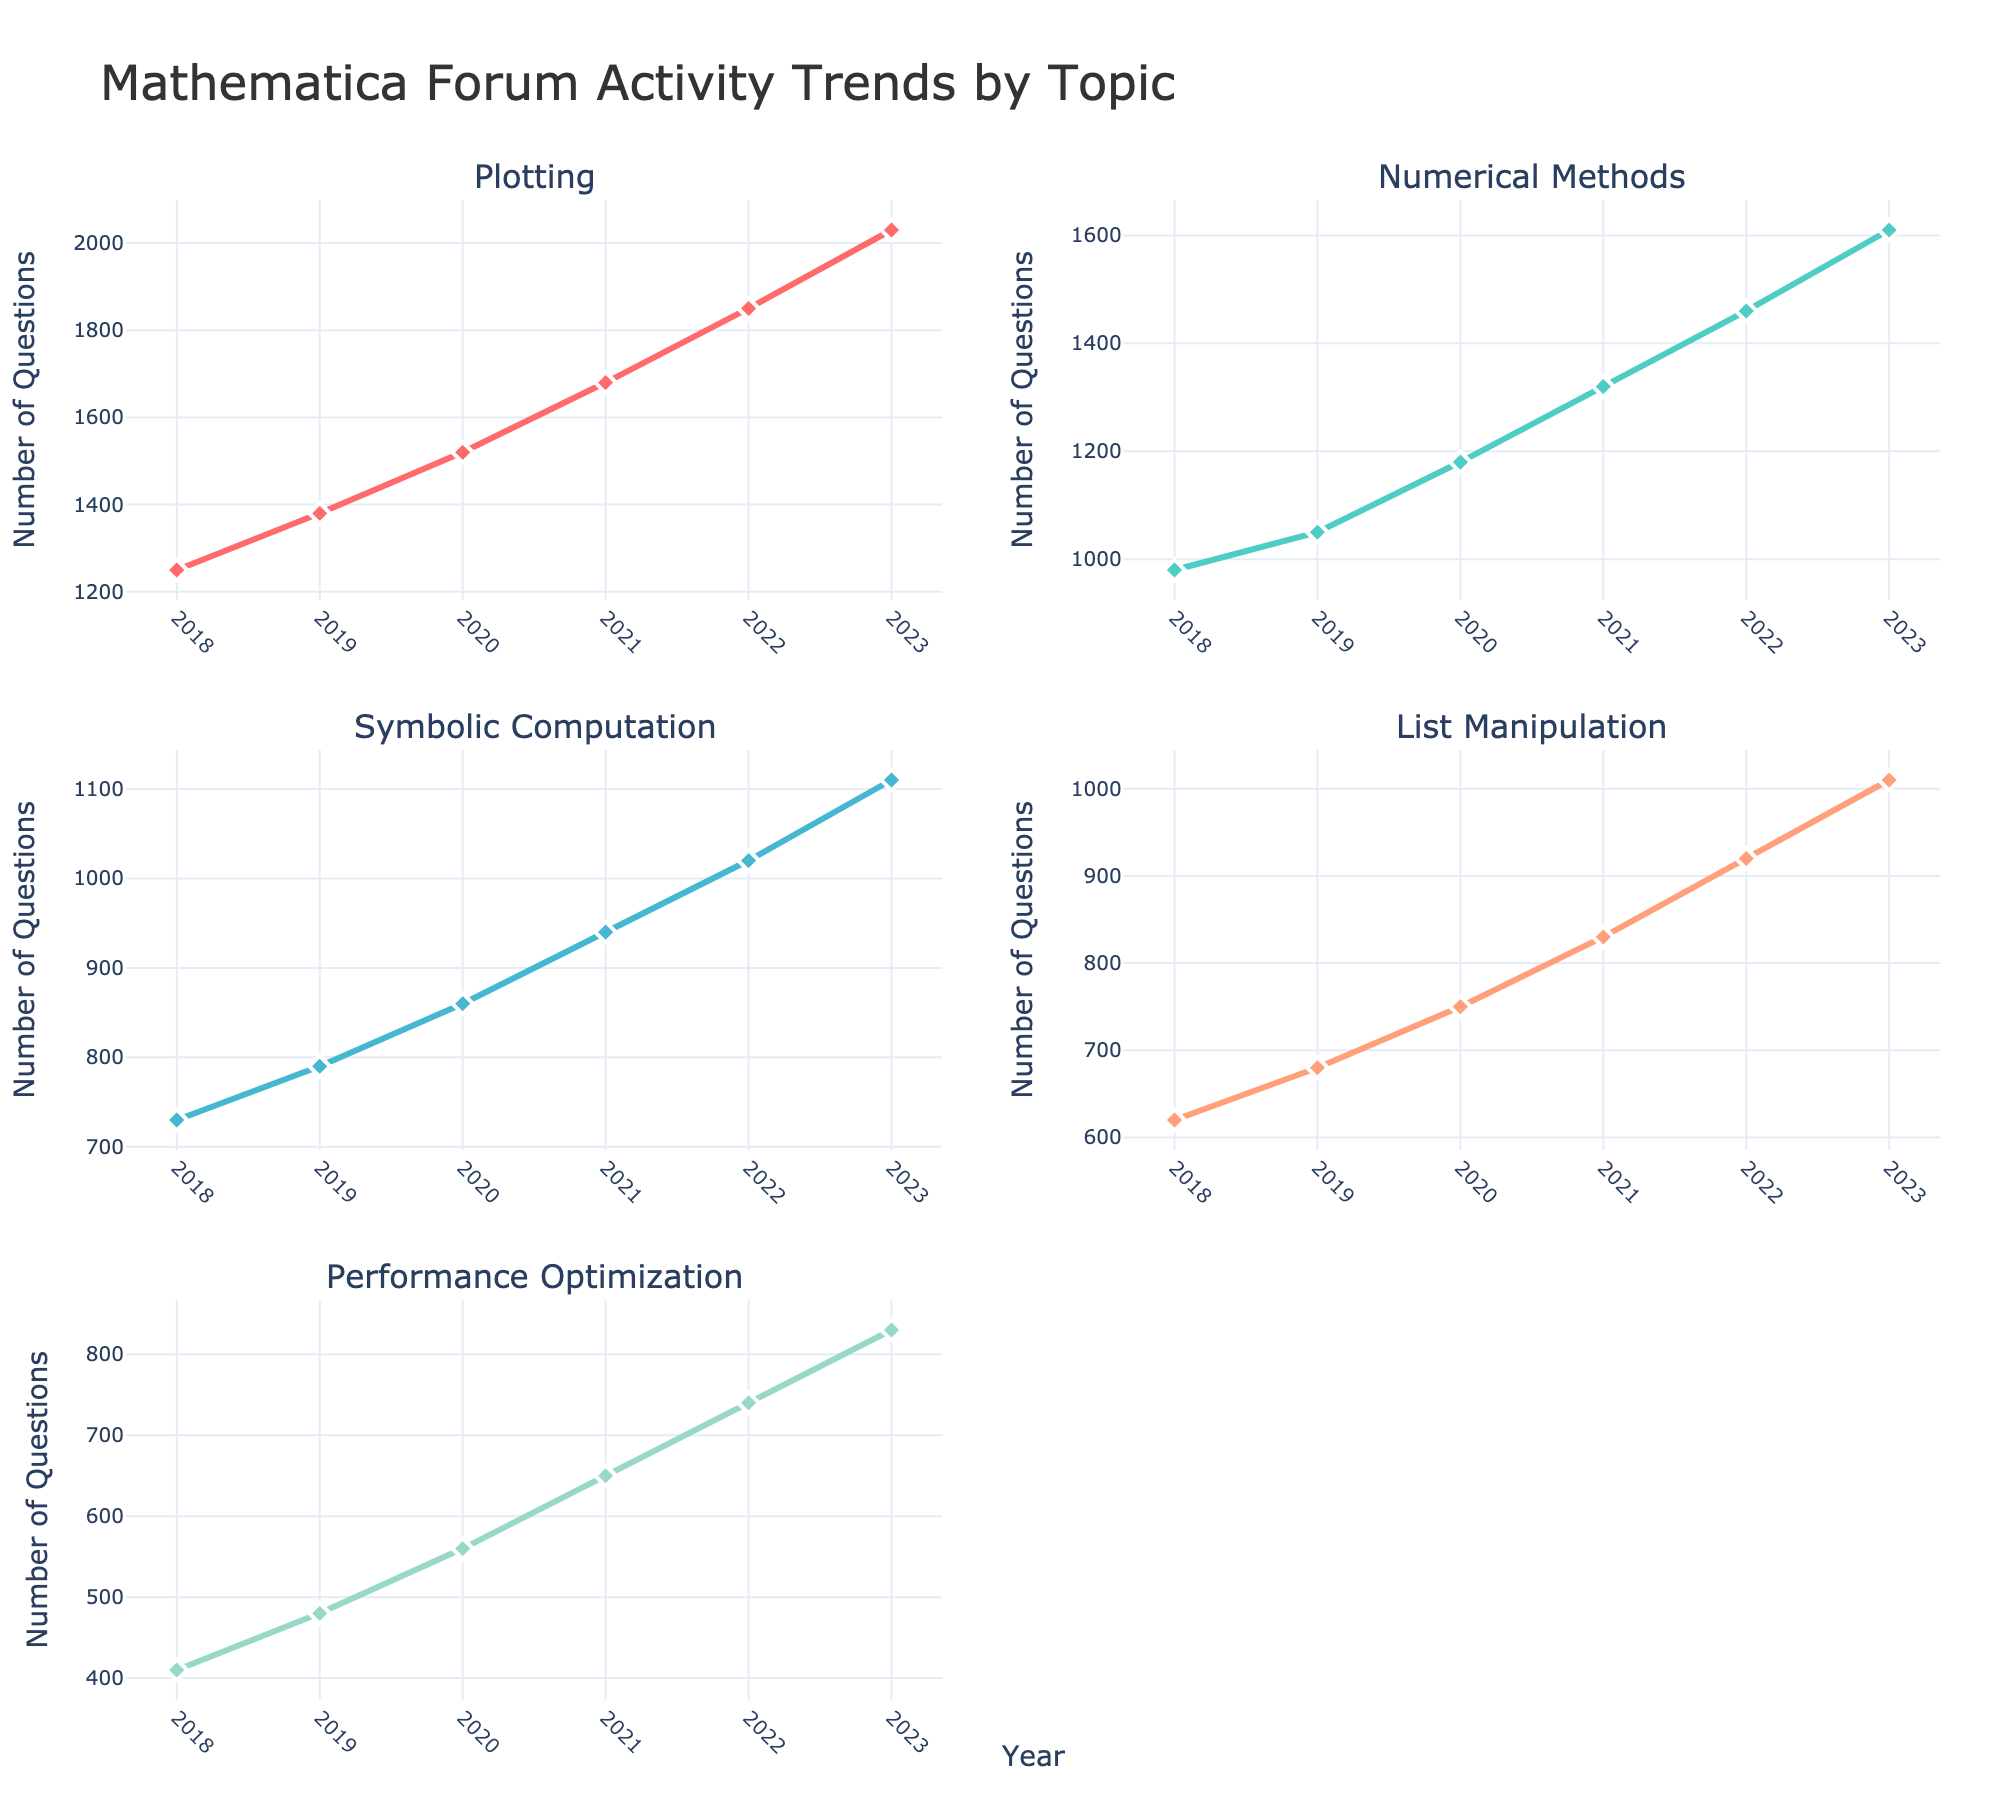what is the title of the figure? The title is normally located at the top of the plot, and it summarizes what the figure is about. Here, it is displayed clearly above all subplots.
Answer: Mathematica Forum Activity Trends by Topic what does the x-axis represent in each subplot? By looking at the common feature across all subplots, the label under each horizontal axis is the same and clarifies what is being measured. The x-axis generally denotes the same variable for consistency.
Answer: Year which topic has the highest number of questions in 2023? Observing the topmost data point in 2023 for each subplot, it is evident which topic’s line is the highest at that year. The corresponding axis title and marker position help identify this topic.
Answer: Plotting what is the total number of questions for the 'Numerical Methods' topic from 2018 to 2023? Summing the values listed for 'Numerical Methods' in each year (980 + 1050 + 1180 + 1320 + 1460 + 1610) gives the total.
Answer: 7600 in which year did 'List Manipulation' see the largest increase in activity compared to the previous year? By examining the vertical distance between consecutive data points for 'List Manipulation,' the year with the largest vertical jump indicates the greatest annual increase.
Answer: 2022 how does the activity trend for 'Performance Optimization' compare from 2018 to 2023? Observing 'Performance Optimization' across the years, noting the slope and direction of the line, tells whether the trend is increasing, decreasing, or stable.
Answer: Increasing in 2020, which topic had fewer questions, 'Symbolic Computation' or 'List Manipulation'? Comparing the data points in 2020 for the two mentioned topics, the lower value indicates fewer questions.
Answer: List Manipulation what is the average number of questions per year for 'Plotting'? Summing the yearly values for 'Plotting' (1250 + 1380 + 1520 + 1680 + 1850 + 2030) and then dividing by the number of years (6) yields the average.
Answer: 1618.33 in which subplot would you find double the number of questions in 2023 compared to 2018? Checking each subplot’s 2023 data point to see if it is roughly double the 2018 value, the number of questions doubling indicates a consistently steep, upward trend.
Answer: Plotting 